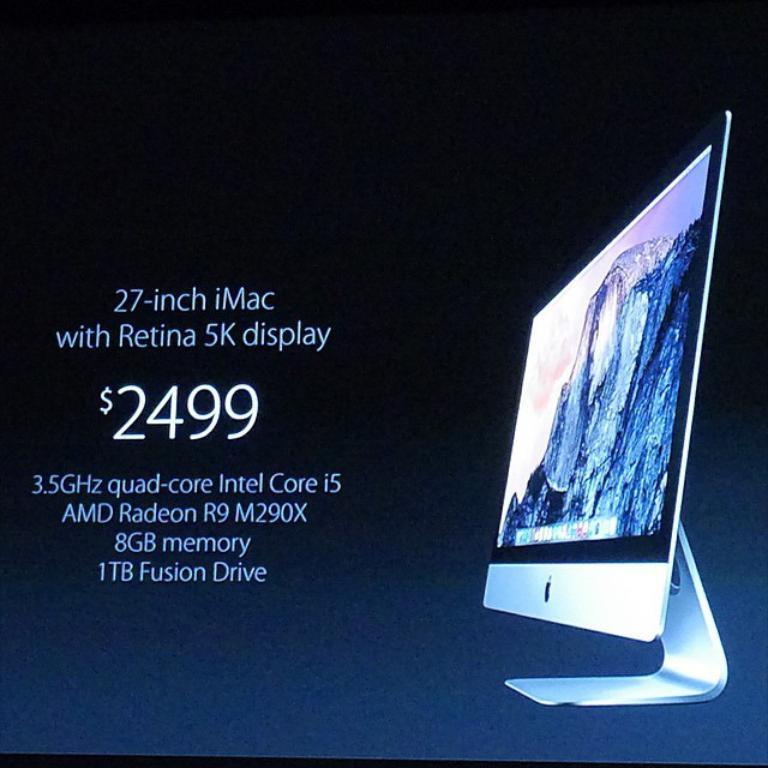Provide a one-sentence caption for the provided image. Imac computer with Retina 5k display for sale. 